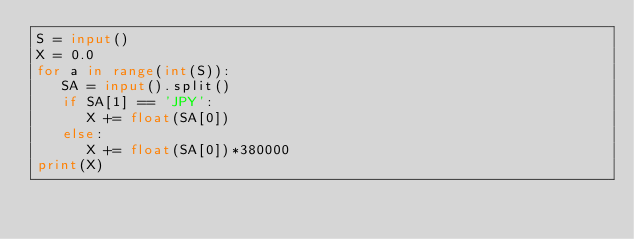Convert code to text. <code><loc_0><loc_0><loc_500><loc_500><_Python_>S = input()
X = 0.0
for a in range(int(S)):
   SA = input().split()
   if SA[1] == 'JPY':
      X += float(SA[0])
   else:
      X += float(SA[0])*380000
print(X)
</code> 